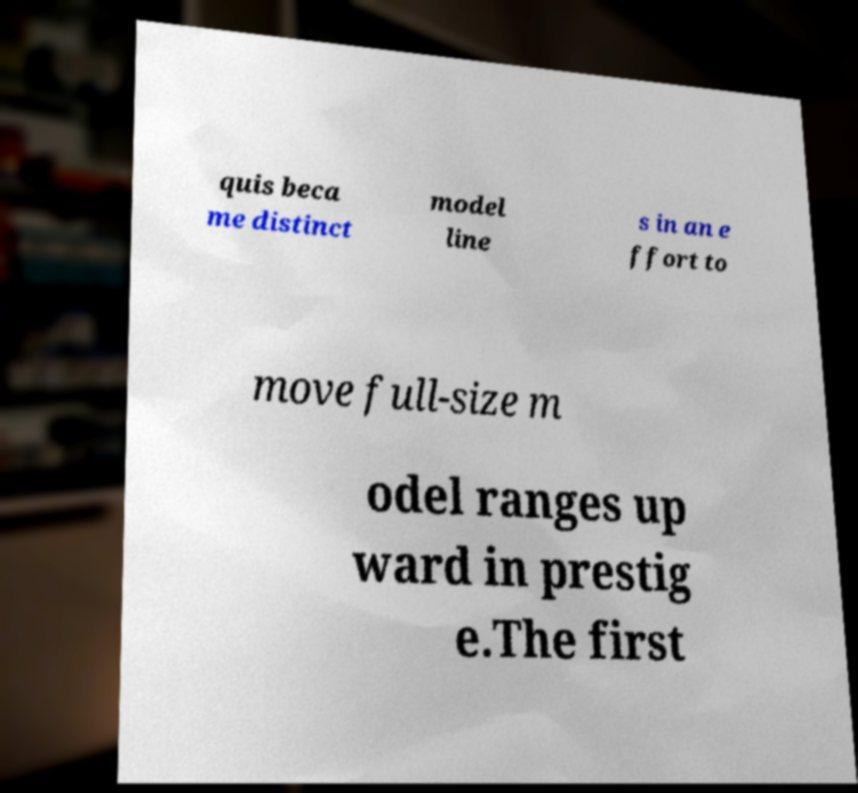Please read and relay the text visible in this image. What does it say? quis beca me distinct model line s in an e ffort to move full-size m odel ranges up ward in prestig e.The first 